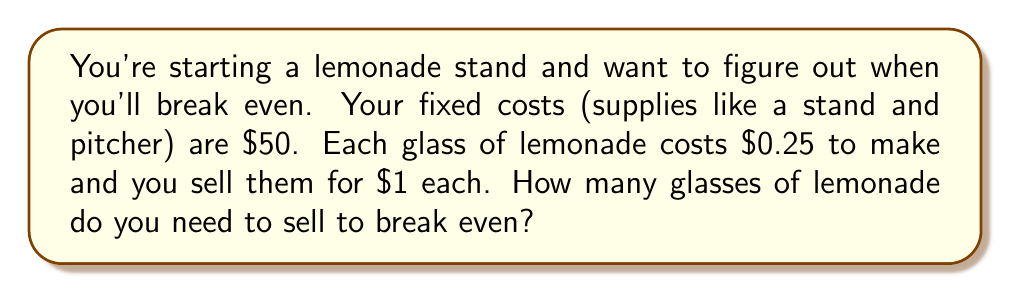Give your solution to this math problem. Let's approach this step-by-step:

1) First, let's define our variables:
   $x$ = number of glasses sold
   $R$ = Revenue
   $C$ = Total Cost
   $F$ = Fixed Cost
   $V$ = Variable Cost per unit

2) We know:
   $F = 50$ (fixed cost)
   $V = 0.25$ (variable cost per glass)
   Price per glass = $1

3) The break-even point occurs when Revenue equals Total Cost:
   $R = C$

4) We can express this as an equation:
   $1x = 50 + 0.25x$

5) Let's solve this equation:
   $1x - 0.25x = 50$
   $0.75x = 50$

6) Divide both sides by 0.75:
   $x = \frac{50}{0.75} = 66.67$

7) Since we can't sell a fraction of a glass, we round up to the next whole number:
   $x = 67$

Therefore, you need to sell 67 glasses of lemonade to break even.
Answer: 67 glasses 